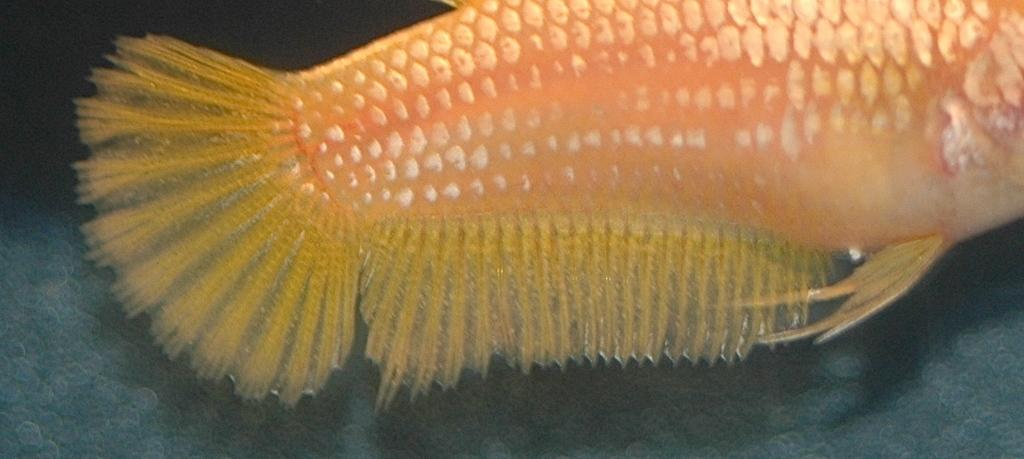What type of animal is present in the image? There is a fish in the image. What type of butter is being used to grease the gate in the image? There is no butter or gate present in the image; it only features a fish. 